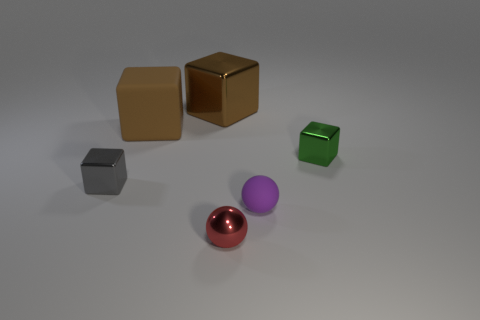Add 1 small purple things. How many objects exist? 7 Subtract all blocks. How many objects are left? 2 Add 1 small green things. How many small green things exist? 2 Subtract 0 green cylinders. How many objects are left? 6 Subtract all big blue metal balls. Subtract all tiny purple rubber balls. How many objects are left? 5 Add 5 blocks. How many blocks are left? 9 